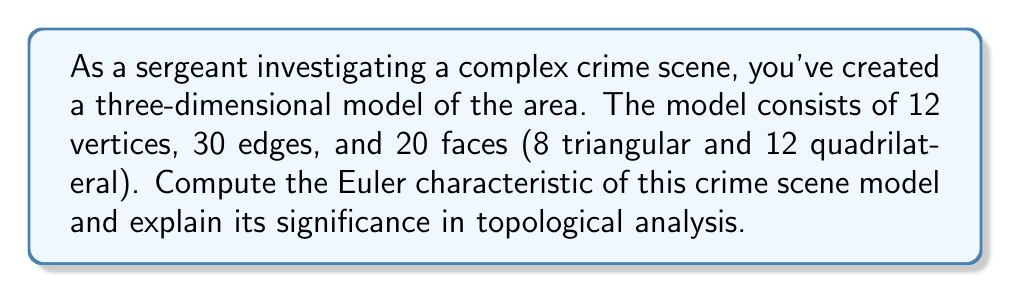Can you solve this math problem? To solve this problem, we'll follow these steps:

1) Recall the Euler characteristic formula for three-dimensional polyhedra:
   $$\chi = V - E + F$$
   where $\chi$ is the Euler characteristic, $V$ is the number of vertices, $E$ is the number of edges, and $F$ is the number of faces.

2) From the given information:
   $V = 12$ (vertices)
   $E = 30$ (edges)
   $F = 20$ (faces: 8 triangular + 12 quadrilateral)

3) Substitute these values into the formula:
   $$\chi = 12 - 30 + 20$$

4) Compute:
   $$\chi = 2$$

The significance of this result in topological analysis:

1) The Euler characteristic is a topological invariant, meaning it doesn't change under continuous deformations of the shape.

2) For a simple, closed polyhedron (like a sphere), the Euler characteristic is always 2. This suggests that our crime scene model is topologically equivalent to a sphere.

3) If the Euler characteristic were different (e.g., 0 for a torus), it would indicate a more complex topology, possibly suggesting hidden spaces or connections in the crime scene.

4) Understanding the topology of the crime scene can help in analyzing potential escape routes, hidden areas, or the overall structure of the crime scene, which could be crucial for the investigation.

5) As a sergeant reflecting on past cases, you might recognize that simple, sphere-like topologies ($\chi = 2$) are more common in standard rooms or buildings, while more complex topologies might indicate unusual architectural features or potential areas of interest in the investigation.
Answer: The Euler characteristic of the crime scene model is $\chi = 2$. 